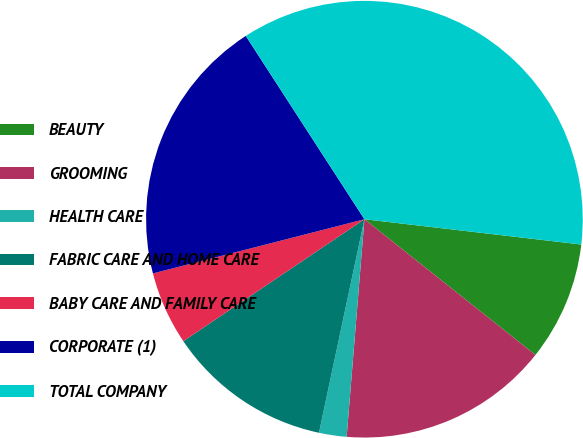Convert chart to OTSL. <chart><loc_0><loc_0><loc_500><loc_500><pie_chart><fcel>BEAUTY<fcel>GROOMING<fcel>HEALTH CARE<fcel>FABRIC CARE AND HOME CARE<fcel>BABY CARE AND FAMILY CARE<fcel>CORPORATE (1)<fcel>TOTAL COMPANY<nl><fcel>8.83%<fcel>15.62%<fcel>2.04%<fcel>12.23%<fcel>5.44%<fcel>19.85%<fcel>35.99%<nl></chart> 